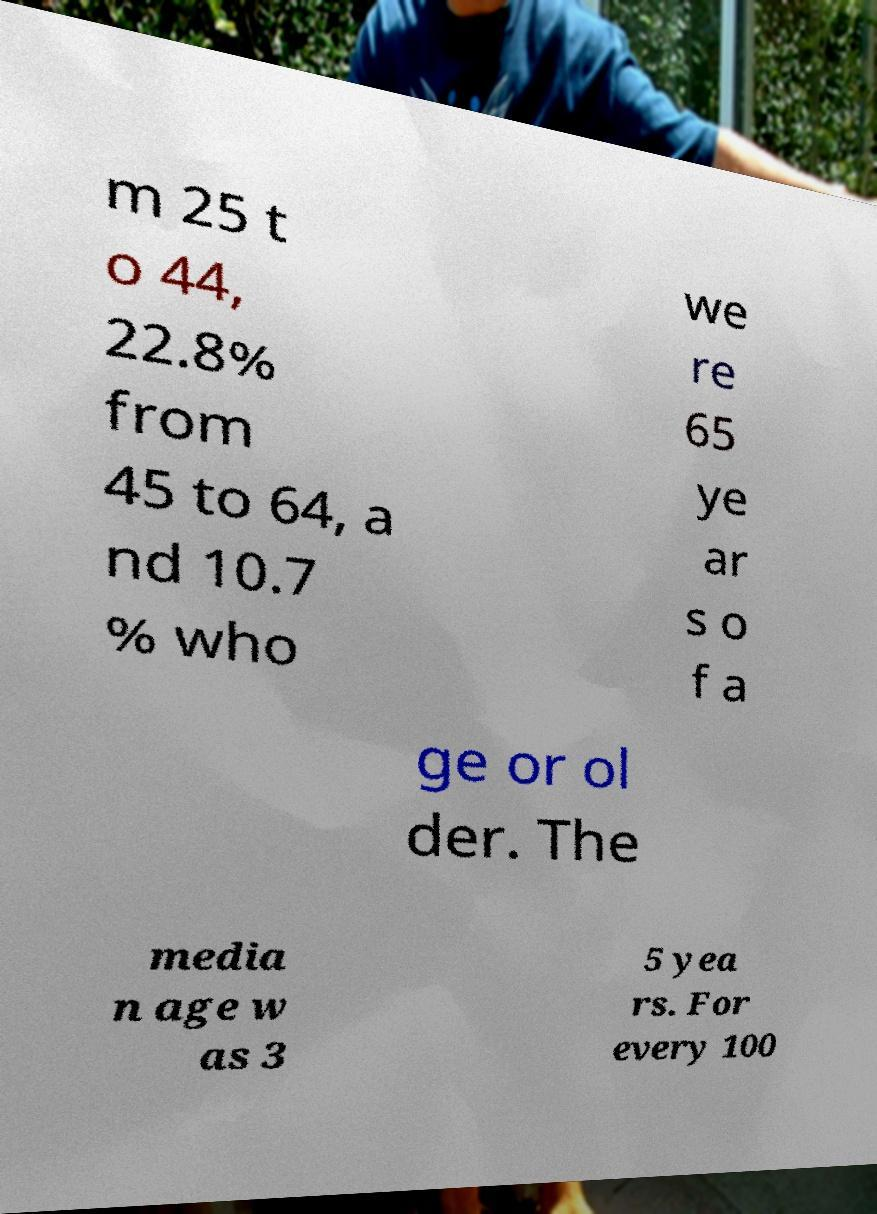For documentation purposes, I need the text within this image transcribed. Could you provide that? m 25 t o 44, 22.8% from 45 to 64, a nd 10.7 % who we re 65 ye ar s o f a ge or ol der. The media n age w as 3 5 yea rs. For every 100 